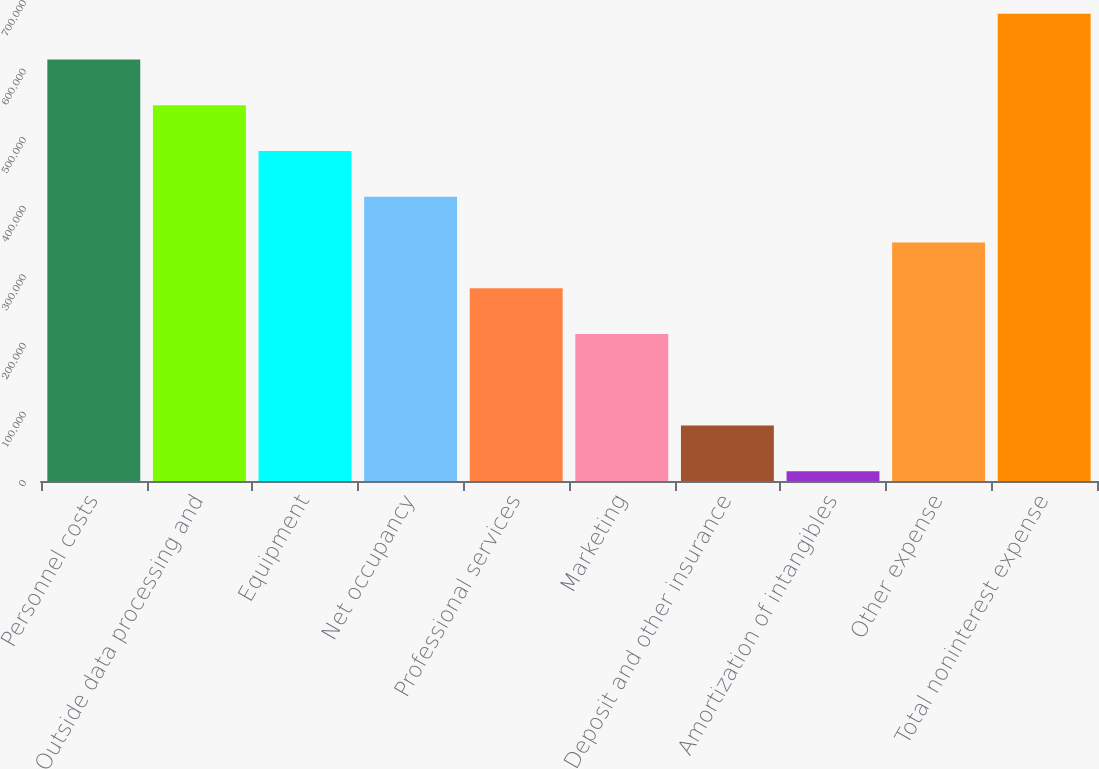<chart> <loc_0><loc_0><loc_500><loc_500><bar_chart><fcel>Personnel costs<fcel>Outside data processing and<fcel>Equipment<fcel>Net occupancy<fcel>Professional services<fcel>Marketing<fcel>Deposit and other insurance<fcel>Amortization of intangibles<fcel>Other expense<fcel>Total noninterest expense<nl><fcel>614757<fcel>548017<fcel>481278<fcel>414538<fcel>281058<fcel>214318<fcel>80838.8<fcel>14099<fcel>347798<fcel>681497<nl></chart> 